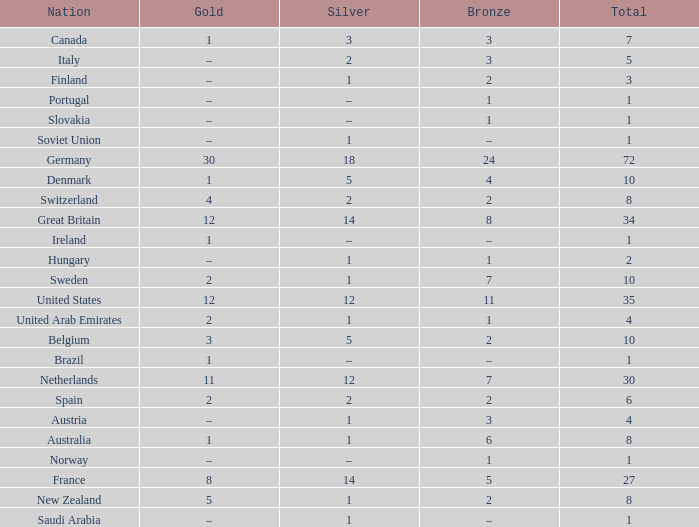What is Gold, when Bronze is 11? 12.0. 